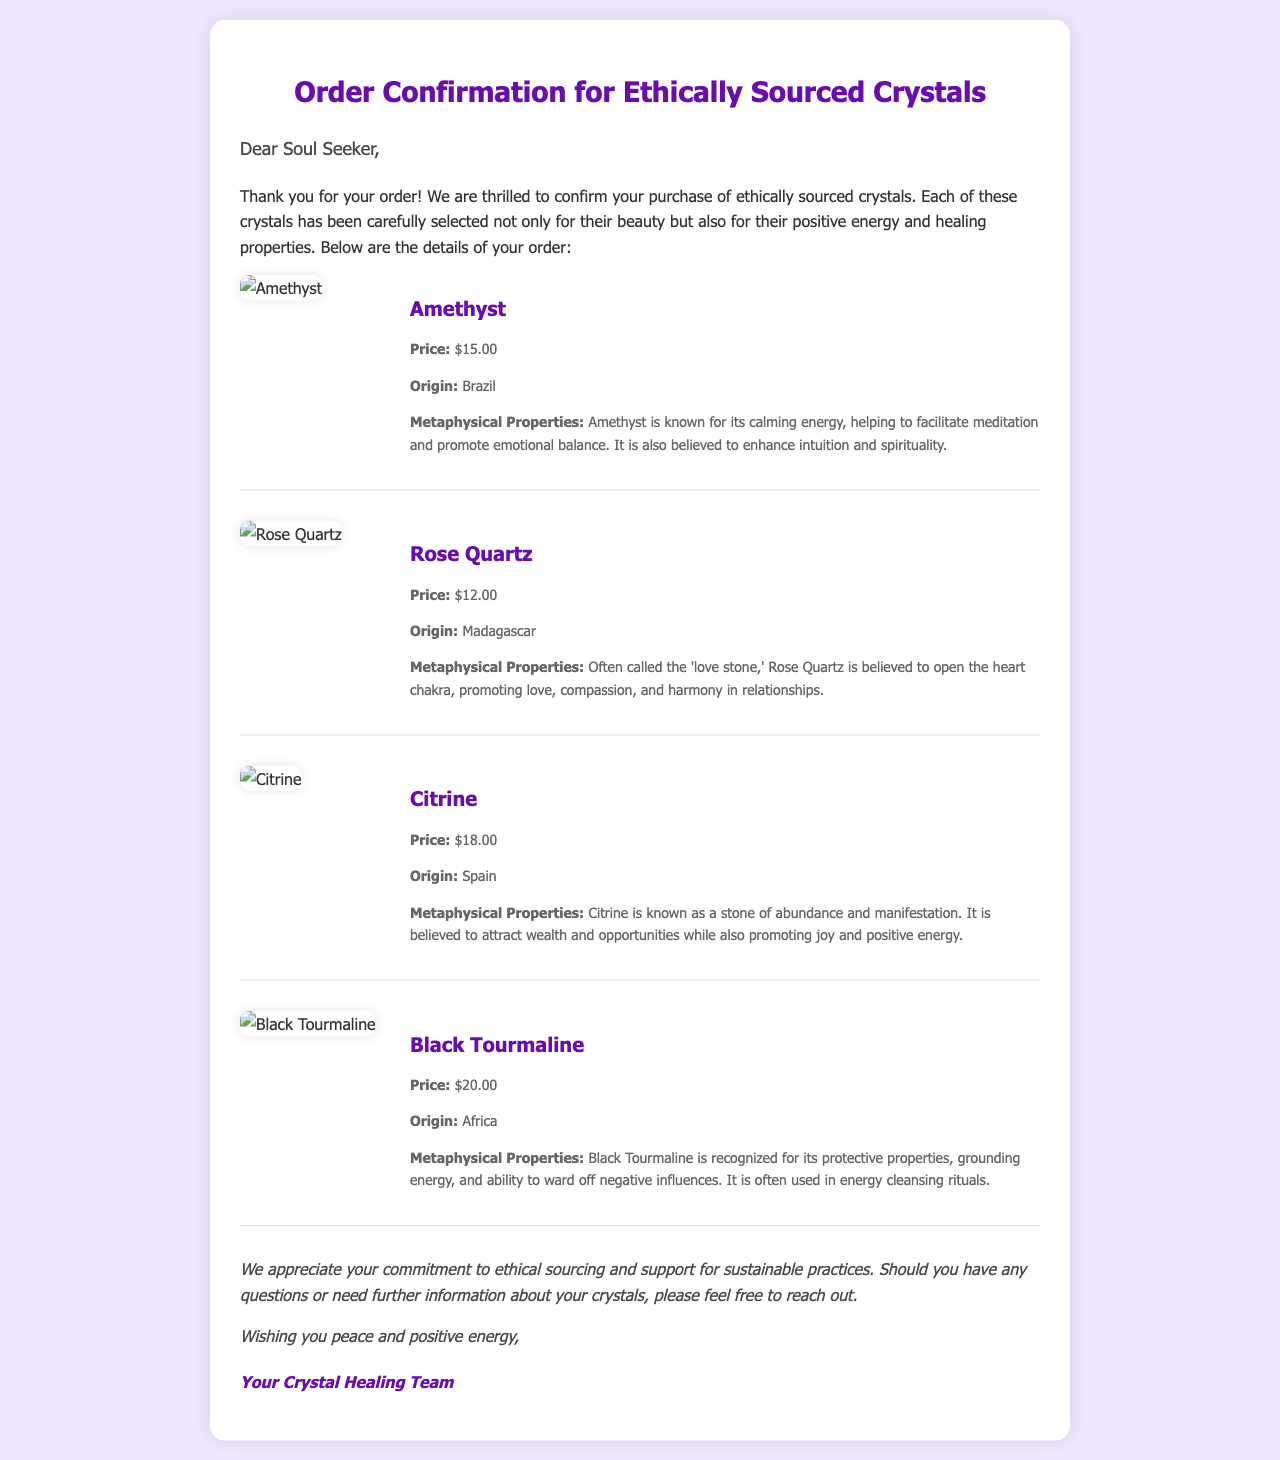What is the price of Amethyst? The price of Amethyst is stated as $15.00 in the document.
Answer: $15.00 What is the origin of Rose Quartz? The origin of Rose Quartz is mentioned as Madagascar in the document.
Answer: Madagascar Which crystal is known as the 'love stone'? The document identifies Rose Quartz as the 'love stone.'
Answer: Rose Quartz What is the metaphysical property of Citrine? The document describes Citrine as a stone of abundance and manifestation that attracts wealth and opportunities.
Answer: Abundance and manifestation What crystals were included in the order? The document lists Amethyst, Rose Quartz, Citrine, and Black Tourmaline as the crystals included in the order.
Answer: Amethyst, Rose Quartz, Citrine, Black Tourmaline What is the total number of crystals ordered? The document mentions four different crystals included in the order.
Answer: Four Which crystal is recognized for its protective properties? The document states that Black Tourmaline is recognized for its protective properties.
Answer: Black Tourmaline What type of document is this? The structure and content indicate that this is an order confirmation email for ethically sourced crystals.
Answer: Order confirmation email 